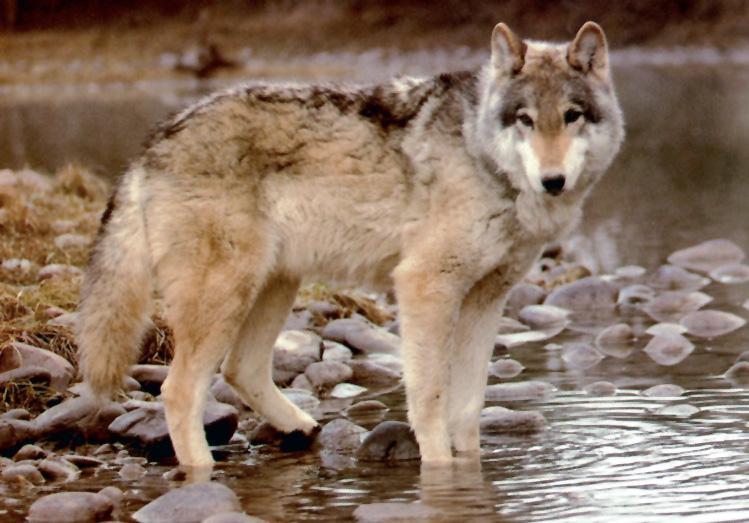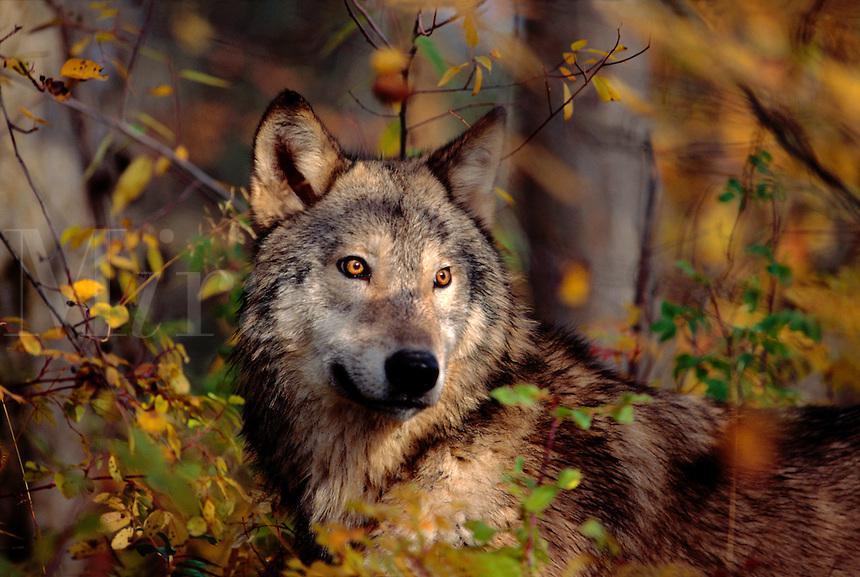The first image is the image on the left, the second image is the image on the right. For the images displayed, is the sentence "At least one of the wolves is visibly standing on snow." factually correct? Answer yes or no. No. 